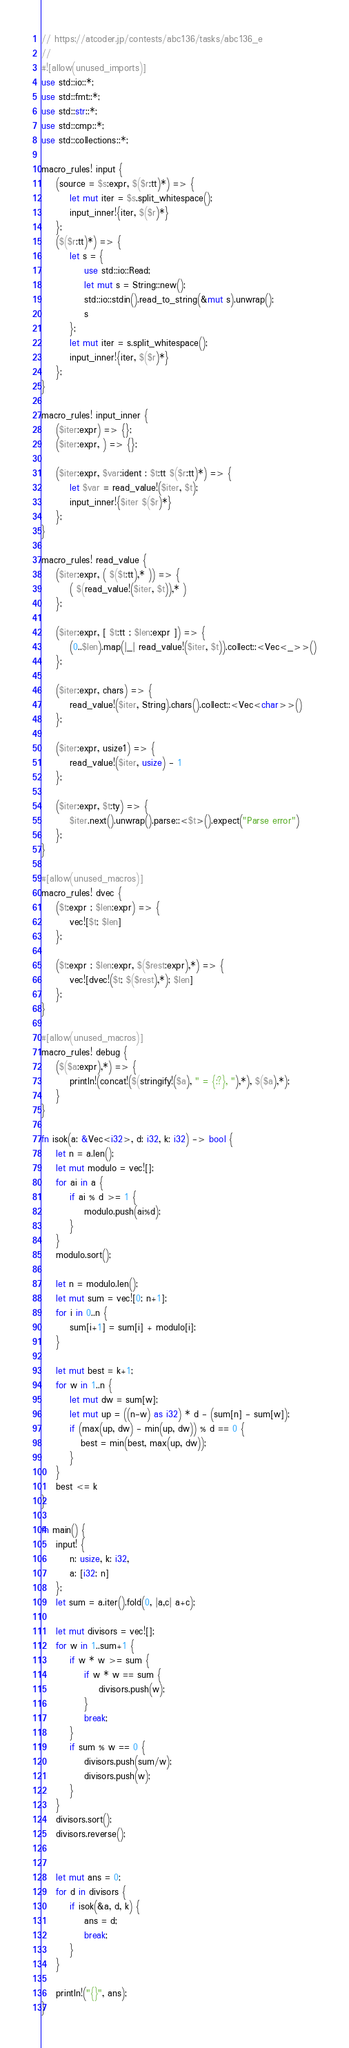<code> <loc_0><loc_0><loc_500><loc_500><_Rust_>// https://atcoder.jp/contests/abc136/tasks/abc136_e
//
#![allow(unused_imports)]
use std::io::*;
use std::fmt::*;
use std::str::*;
use std::cmp::*;
use std::collections::*;

macro_rules! input {
    (source = $s:expr, $($r:tt)*) => {
        let mut iter = $s.split_whitespace();
        input_inner!{iter, $($r)*}
    };
    ($($r:tt)*) => {
        let s = {
            use std::io::Read;
            let mut s = String::new();
            std::io::stdin().read_to_string(&mut s).unwrap();
            s
        };
        let mut iter = s.split_whitespace();
        input_inner!{iter, $($r)*}
    };
}

macro_rules! input_inner {
    ($iter:expr) => {};
    ($iter:expr, ) => {};

    ($iter:expr, $var:ident : $t:tt $($r:tt)*) => {
        let $var = read_value!($iter, $t);
        input_inner!{$iter $($r)*}
    };
}

macro_rules! read_value {
    ($iter:expr, ( $($t:tt),* )) => {
        ( $(read_value!($iter, $t)),* )
    };

    ($iter:expr, [ $t:tt ; $len:expr ]) => {
        (0..$len).map(|_| read_value!($iter, $t)).collect::<Vec<_>>()
    };

    ($iter:expr, chars) => {
        read_value!($iter, String).chars().collect::<Vec<char>>()
    };

    ($iter:expr, usize1) => {
        read_value!($iter, usize) - 1
    };

    ($iter:expr, $t:ty) => {
        $iter.next().unwrap().parse::<$t>().expect("Parse error")
    };
}

#[allow(unused_macros)]
macro_rules! dvec {
    ($t:expr ; $len:expr) => {
        vec![$t; $len]
    };

    ($t:expr ; $len:expr, $($rest:expr),*) => {
        vec![dvec!($t; $($rest),*); $len]
    };
}

#[allow(unused_macros)]
macro_rules! debug {
    ($($a:expr),*) => {
        println!(concat!($(stringify!($a), " = {:?}, "),*), $($a),*);
    }
}

fn isok(a: &Vec<i32>, d: i32, k: i32) -> bool {
    let n = a.len();
    let mut modulo = vec![];
    for ai in a {
        if ai % d >= 1 {
            modulo.push(ai%d);
        }
    }
    modulo.sort();

    let n = modulo.len();
    let mut sum = vec![0; n+1];
    for i in 0..n {
        sum[i+1] = sum[i] + modulo[i];
    }

    let mut best = k+1;
    for w in 1..n {
        let mut dw = sum[w];
        let mut up = ((n-w) as i32) * d - (sum[n] - sum[w]);
        if (max(up, dw) - min(up, dw)) % d == 0 {
           best = min(best, max(up, dw));
        }
    }
    best <= k
}

fn main() {
    input! {
        n: usize, k: i32,
        a: [i32; n]
    };
    let sum = a.iter().fold(0, |a,c| a+c);

    let mut divisors = vec![];
    for w in 1..sum+1 {
        if w * w >= sum {
            if w * w == sum {
                divisors.push(w);
            }
            break;
        }
        if sum % w == 0 {
            divisors.push(sum/w);
            divisors.push(w);
        }
    }
    divisors.sort();
    divisors.reverse();


    let mut ans = 0;
    for d in divisors {
        if isok(&a, d, k) {
            ans = d;
            break;
        }
    }

    println!("{}", ans);
}
</code> 